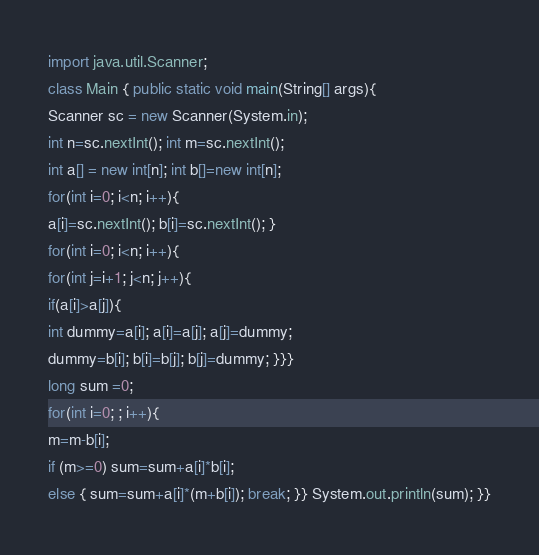Convert code to text. <code><loc_0><loc_0><loc_500><loc_500><_Java_>import java.util.Scanner; 
class Main { public static void main(String[] args){ 
Scanner sc = new Scanner(System.in); 
int n=sc.nextInt(); int m=sc.nextInt(); 
int a[] = new int[n]; int b[]=new int[n]; 
for(int i=0; i<n; i++){ 
a[i]=sc.nextInt(); b[i]=sc.nextInt(); } 
for(int i=0; i<n; i++){ 
for(int j=i+1; j<n; j++){ 
if(a[i]>a[j]){ 
int dummy=a[i]; a[i]=a[j]; a[j]=dummy; 
dummy=b[i]; b[i]=b[j]; b[j]=dummy; }}} 
long sum =0; 
for(int i=0; ; i++){ 
m=m-b[i]; 
if (m>=0) sum=sum+a[i]*b[i]; 
else { sum=sum+a[i]*(m+b[i]); break; }} System.out.println(sum); }}
</code> 